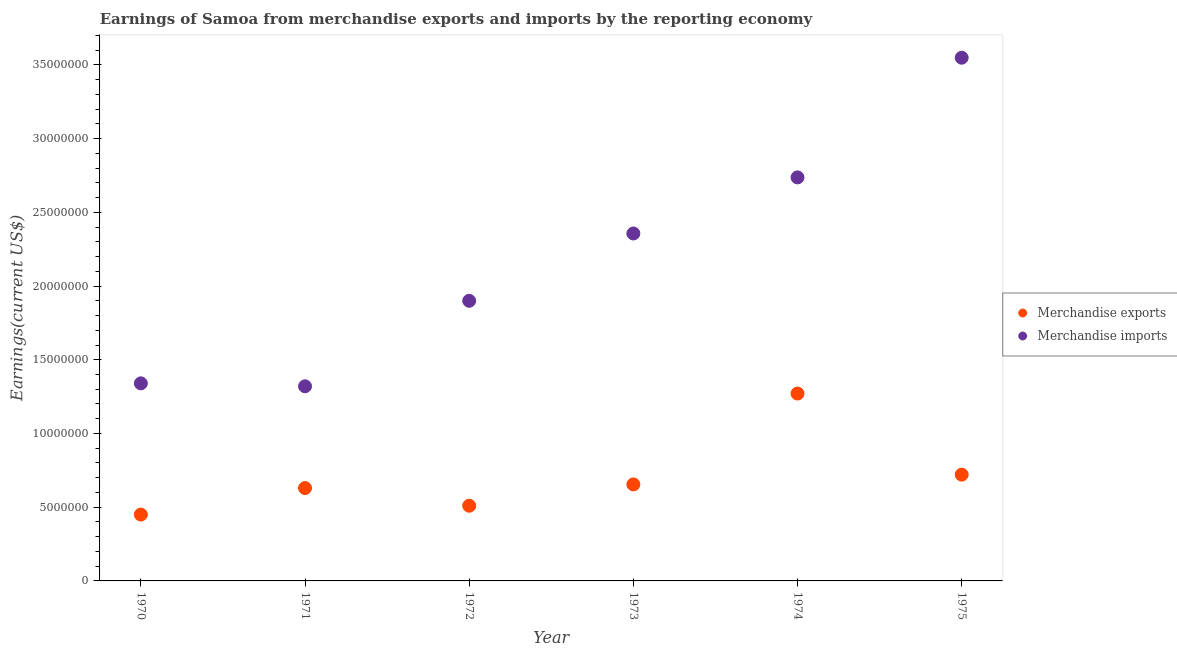What is the earnings from merchandise exports in 1972?
Your answer should be compact. 5.10e+06. Across all years, what is the maximum earnings from merchandise imports?
Ensure brevity in your answer.  3.55e+07. Across all years, what is the minimum earnings from merchandise imports?
Provide a short and direct response. 1.32e+07. In which year was the earnings from merchandise imports maximum?
Offer a terse response. 1975. In which year was the earnings from merchandise imports minimum?
Make the answer very short. 1971. What is the total earnings from merchandise exports in the graph?
Keep it short and to the point. 4.24e+07. What is the difference between the earnings from merchandise exports in 1972 and the earnings from merchandise imports in 1970?
Make the answer very short. -8.30e+06. What is the average earnings from merchandise imports per year?
Your answer should be very brief. 2.20e+07. In the year 1973, what is the difference between the earnings from merchandise exports and earnings from merchandise imports?
Your answer should be compact. -1.70e+07. What is the ratio of the earnings from merchandise exports in 1973 to that in 1974?
Your answer should be compact. 0.51. Is the earnings from merchandise exports in 1973 less than that in 1975?
Ensure brevity in your answer.  Yes. What is the difference between the highest and the second highest earnings from merchandise exports?
Offer a very short reply. 5.50e+06. What is the difference between the highest and the lowest earnings from merchandise imports?
Offer a very short reply. 2.23e+07. Does the earnings from merchandise exports monotonically increase over the years?
Your answer should be very brief. No. Is the earnings from merchandise imports strictly less than the earnings from merchandise exports over the years?
Offer a terse response. No. How many dotlines are there?
Your answer should be compact. 2. How many years are there in the graph?
Offer a terse response. 6. Are the values on the major ticks of Y-axis written in scientific E-notation?
Give a very brief answer. No. Does the graph contain any zero values?
Ensure brevity in your answer.  No. How many legend labels are there?
Your response must be concise. 2. How are the legend labels stacked?
Ensure brevity in your answer.  Vertical. What is the title of the graph?
Your answer should be very brief. Earnings of Samoa from merchandise exports and imports by the reporting economy. What is the label or title of the Y-axis?
Provide a succinct answer. Earnings(current US$). What is the Earnings(current US$) of Merchandise exports in 1970?
Make the answer very short. 4.50e+06. What is the Earnings(current US$) in Merchandise imports in 1970?
Provide a succinct answer. 1.34e+07. What is the Earnings(current US$) in Merchandise exports in 1971?
Offer a terse response. 6.30e+06. What is the Earnings(current US$) in Merchandise imports in 1971?
Your answer should be compact. 1.32e+07. What is the Earnings(current US$) in Merchandise exports in 1972?
Your answer should be compact. 5.10e+06. What is the Earnings(current US$) of Merchandise imports in 1972?
Keep it short and to the point. 1.90e+07. What is the Earnings(current US$) in Merchandise exports in 1973?
Your answer should be compact. 6.54e+06. What is the Earnings(current US$) of Merchandise imports in 1973?
Make the answer very short. 2.36e+07. What is the Earnings(current US$) in Merchandise exports in 1974?
Your answer should be compact. 1.27e+07. What is the Earnings(current US$) of Merchandise imports in 1974?
Make the answer very short. 2.74e+07. What is the Earnings(current US$) in Merchandise exports in 1975?
Provide a short and direct response. 7.21e+06. What is the Earnings(current US$) of Merchandise imports in 1975?
Make the answer very short. 3.55e+07. Across all years, what is the maximum Earnings(current US$) of Merchandise exports?
Your answer should be compact. 1.27e+07. Across all years, what is the maximum Earnings(current US$) in Merchandise imports?
Keep it short and to the point. 3.55e+07. Across all years, what is the minimum Earnings(current US$) in Merchandise exports?
Ensure brevity in your answer.  4.50e+06. Across all years, what is the minimum Earnings(current US$) in Merchandise imports?
Your response must be concise. 1.32e+07. What is the total Earnings(current US$) in Merchandise exports in the graph?
Provide a short and direct response. 4.24e+07. What is the total Earnings(current US$) of Merchandise imports in the graph?
Offer a very short reply. 1.32e+08. What is the difference between the Earnings(current US$) in Merchandise exports in 1970 and that in 1971?
Your response must be concise. -1.80e+06. What is the difference between the Earnings(current US$) of Merchandise imports in 1970 and that in 1971?
Provide a succinct answer. 2.00e+05. What is the difference between the Earnings(current US$) of Merchandise exports in 1970 and that in 1972?
Provide a succinct answer. -6.00e+05. What is the difference between the Earnings(current US$) in Merchandise imports in 1970 and that in 1972?
Your answer should be compact. -5.60e+06. What is the difference between the Earnings(current US$) of Merchandise exports in 1970 and that in 1973?
Ensure brevity in your answer.  -2.04e+06. What is the difference between the Earnings(current US$) in Merchandise imports in 1970 and that in 1973?
Provide a succinct answer. -1.02e+07. What is the difference between the Earnings(current US$) in Merchandise exports in 1970 and that in 1974?
Ensure brevity in your answer.  -8.21e+06. What is the difference between the Earnings(current US$) of Merchandise imports in 1970 and that in 1974?
Ensure brevity in your answer.  -1.40e+07. What is the difference between the Earnings(current US$) in Merchandise exports in 1970 and that in 1975?
Your response must be concise. -2.71e+06. What is the difference between the Earnings(current US$) in Merchandise imports in 1970 and that in 1975?
Give a very brief answer. -2.21e+07. What is the difference between the Earnings(current US$) in Merchandise exports in 1971 and that in 1972?
Provide a succinct answer. 1.20e+06. What is the difference between the Earnings(current US$) of Merchandise imports in 1971 and that in 1972?
Make the answer very short. -5.80e+06. What is the difference between the Earnings(current US$) in Merchandise exports in 1971 and that in 1973?
Give a very brief answer. -2.45e+05. What is the difference between the Earnings(current US$) in Merchandise imports in 1971 and that in 1973?
Make the answer very short. -1.04e+07. What is the difference between the Earnings(current US$) in Merchandise exports in 1971 and that in 1974?
Provide a succinct answer. -6.41e+06. What is the difference between the Earnings(current US$) of Merchandise imports in 1971 and that in 1974?
Provide a succinct answer. -1.42e+07. What is the difference between the Earnings(current US$) of Merchandise exports in 1971 and that in 1975?
Provide a succinct answer. -9.08e+05. What is the difference between the Earnings(current US$) in Merchandise imports in 1971 and that in 1975?
Your response must be concise. -2.23e+07. What is the difference between the Earnings(current US$) in Merchandise exports in 1972 and that in 1973?
Give a very brief answer. -1.44e+06. What is the difference between the Earnings(current US$) in Merchandise imports in 1972 and that in 1973?
Give a very brief answer. -4.56e+06. What is the difference between the Earnings(current US$) in Merchandise exports in 1972 and that in 1974?
Your answer should be compact. -7.61e+06. What is the difference between the Earnings(current US$) of Merchandise imports in 1972 and that in 1974?
Your answer should be compact. -8.37e+06. What is the difference between the Earnings(current US$) in Merchandise exports in 1972 and that in 1975?
Provide a succinct answer. -2.11e+06. What is the difference between the Earnings(current US$) in Merchandise imports in 1972 and that in 1975?
Ensure brevity in your answer.  -1.65e+07. What is the difference between the Earnings(current US$) of Merchandise exports in 1973 and that in 1974?
Provide a succinct answer. -6.16e+06. What is the difference between the Earnings(current US$) in Merchandise imports in 1973 and that in 1974?
Ensure brevity in your answer.  -3.80e+06. What is the difference between the Earnings(current US$) of Merchandise exports in 1973 and that in 1975?
Your answer should be compact. -6.63e+05. What is the difference between the Earnings(current US$) of Merchandise imports in 1973 and that in 1975?
Offer a very short reply. -1.19e+07. What is the difference between the Earnings(current US$) of Merchandise exports in 1974 and that in 1975?
Ensure brevity in your answer.  5.50e+06. What is the difference between the Earnings(current US$) in Merchandise imports in 1974 and that in 1975?
Your answer should be compact. -8.12e+06. What is the difference between the Earnings(current US$) of Merchandise exports in 1970 and the Earnings(current US$) of Merchandise imports in 1971?
Make the answer very short. -8.70e+06. What is the difference between the Earnings(current US$) of Merchandise exports in 1970 and the Earnings(current US$) of Merchandise imports in 1972?
Provide a succinct answer. -1.45e+07. What is the difference between the Earnings(current US$) in Merchandise exports in 1970 and the Earnings(current US$) in Merchandise imports in 1973?
Keep it short and to the point. -1.91e+07. What is the difference between the Earnings(current US$) in Merchandise exports in 1970 and the Earnings(current US$) in Merchandise imports in 1974?
Ensure brevity in your answer.  -2.29e+07. What is the difference between the Earnings(current US$) in Merchandise exports in 1970 and the Earnings(current US$) in Merchandise imports in 1975?
Make the answer very short. -3.10e+07. What is the difference between the Earnings(current US$) of Merchandise exports in 1971 and the Earnings(current US$) of Merchandise imports in 1972?
Your response must be concise. -1.27e+07. What is the difference between the Earnings(current US$) in Merchandise exports in 1971 and the Earnings(current US$) in Merchandise imports in 1973?
Your answer should be compact. -1.73e+07. What is the difference between the Earnings(current US$) of Merchandise exports in 1971 and the Earnings(current US$) of Merchandise imports in 1974?
Ensure brevity in your answer.  -2.11e+07. What is the difference between the Earnings(current US$) in Merchandise exports in 1971 and the Earnings(current US$) in Merchandise imports in 1975?
Your answer should be very brief. -2.92e+07. What is the difference between the Earnings(current US$) of Merchandise exports in 1972 and the Earnings(current US$) of Merchandise imports in 1973?
Your answer should be compact. -1.85e+07. What is the difference between the Earnings(current US$) in Merchandise exports in 1972 and the Earnings(current US$) in Merchandise imports in 1974?
Your answer should be compact. -2.23e+07. What is the difference between the Earnings(current US$) of Merchandise exports in 1972 and the Earnings(current US$) of Merchandise imports in 1975?
Your answer should be very brief. -3.04e+07. What is the difference between the Earnings(current US$) in Merchandise exports in 1973 and the Earnings(current US$) in Merchandise imports in 1974?
Give a very brief answer. -2.08e+07. What is the difference between the Earnings(current US$) of Merchandise exports in 1973 and the Earnings(current US$) of Merchandise imports in 1975?
Provide a short and direct response. -2.89e+07. What is the difference between the Earnings(current US$) of Merchandise exports in 1974 and the Earnings(current US$) of Merchandise imports in 1975?
Provide a short and direct response. -2.28e+07. What is the average Earnings(current US$) in Merchandise exports per year?
Your answer should be very brief. 7.06e+06. What is the average Earnings(current US$) in Merchandise imports per year?
Provide a short and direct response. 2.20e+07. In the year 1970, what is the difference between the Earnings(current US$) in Merchandise exports and Earnings(current US$) in Merchandise imports?
Provide a short and direct response. -8.90e+06. In the year 1971, what is the difference between the Earnings(current US$) of Merchandise exports and Earnings(current US$) of Merchandise imports?
Ensure brevity in your answer.  -6.90e+06. In the year 1972, what is the difference between the Earnings(current US$) of Merchandise exports and Earnings(current US$) of Merchandise imports?
Your answer should be compact. -1.39e+07. In the year 1973, what is the difference between the Earnings(current US$) of Merchandise exports and Earnings(current US$) of Merchandise imports?
Ensure brevity in your answer.  -1.70e+07. In the year 1974, what is the difference between the Earnings(current US$) in Merchandise exports and Earnings(current US$) in Merchandise imports?
Your answer should be very brief. -1.47e+07. In the year 1975, what is the difference between the Earnings(current US$) in Merchandise exports and Earnings(current US$) in Merchandise imports?
Your answer should be compact. -2.83e+07. What is the ratio of the Earnings(current US$) of Merchandise exports in 1970 to that in 1971?
Offer a very short reply. 0.71. What is the ratio of the Earnings(current US$) in Merchandise imports in 1970 to that in 1971?
Give a very brief answer. 1.02. What is the ratio of the Earnings(current US$) of Merchandise exports in 1970 to that in 1972?
Keep it short and to the point. 0.88. What is the ratio of the Earnings(current US$) in Merchandise imports in 1970 to that in 1972?
Offer a very short reply. 0.71. What is the ratio of the Earnings(current US$) in Merchandise exports in 1970 to that in 1973?
Ensure brevity in your answer.  0.69. What is the ratio of the Earnings(current US$) of Merchandise imports in 1970 to that in 1973?
Ensure brevity in your answer.  0.57. What is the ratio of the Earnings(current US$) of Merchandise exports in 1970 to that in 1974?
Give a very brief answer. 0.35. What is the ratio of the Earnings(current US$) in Merchandise imports in 1970 to that in 1974?
Keep it short and to the point. 0.49. What is the ratio of the Earnings(current US$) in Merchandise exports in 1970 to that in 1975?
Make the answer very short. 0.62. What is the ratio of the Earnings(current US$) of Merchandise imports in 1970 to that in 1975?
Provide a succinct answer. 0.38. What is the ratio of the Earnings(current US$) of Merchandise exports in 1971 to that in 1972?
Give a very brief answer. 1.24. What is the ratio of the Earnings(current US$) in Merchandise imports in 1971 to that in 1972?
Provide a succinct answer. 0.69. What is the ratio of the Earnings(current US$) of Merchandise exports in 1971 to that in 1973?
Offer a terse response. 0.96. What is the ratio of the Earnings(current US$) in Merchandise imports in 1971 to that in 1973?
Give a very brief answer. 0.56. What is the ratio of the Earnings(current US$) in Merchandise exports in 1971 to that in 1974?
Your answer should be very brief. 0.5. What is the ratio of the Earnings(current US$) in Merchandise imports in 1971 to that in 1974?
Make the answer very short. 0.48. What is the ratio of the Earnings(current US$) in Merchandise exports in 1971 to that in 1975?
Your answer should be very brief. 0.87. What is the ratio of the Earnings(current US$) of Merchandise imports in 1971 to that in 1975?
Provide a short and direct response. 0.37. What is the ratio of the Earnings(current US$) in Merchandise exports in 1972 to that in 1973?
Provide a short and direct response. 0.78. What is the ratio of the Earnings(current US$) in Merchandise imports in 1972 to that in 1973?
Offer a very short reply. 0.81. What is the ratio of the Earnings(current US$) of Merchandise exports in 1972 to that in 1974?
Provide a short and direct response. 0.4. What is the ratio of the Earnings(current US$) of Merchandise imports in 1972 to that in 1974?
Offer a terse response. 0.69. What is the ratio of the Earnings(current US$) in Merchandise exports in 1972 to that in 1975?
Offer a terse response. 0.71. What is the ratio of the Earnings(current US$) in Merchandise imports in 1972 to that in 1975?
Keep it short and to the point. 0.54. What is the ratio of the Earnings(current US$) of Merchandise exports in 1973 to that in 1974?
Your answer should be very brief. 0.52. What is the ratio of the Earnings(current US$) in Merchandise imports in 1973 to that in 1974?
Your answer should be very brief. 0.86. What is the ratio of the Earnings(current US$) in Merchandise exports in 1973 to that in 1975?
Ensure brevity in your answer.  0.91. What is the ratio of the Earnings(current US$) of Merchandise imports in 1973 to that in 1975?
Provide a succinct answer. 0.66. What is the ratio of the Earnings(current US$) in Merchandise exports in 1974 to that in 1975?
Offer a very short reply. 1.76. What is the ratio of the Earnings(current US$) of Merchandise imports in 1974 to that in 1975?
Give a very brief answer. 0.77. What is the difference between the highest and the second highest Earnings(current US$) in Merchandise exports?
Give a very brief answer. 5.50e+06. What is the difference between the highest and the second highest Earnings(current US$) of Merchandise imports?
Keep it short and to the point. 8.12e+06. What is the difference between the highest and the lowest Earnings(current US$) in Merchandise exports?
Make the answer very short. 8.21e+06. What is the difference between the highest and the lowest Earnings(current US$) in Merchandise imports?
Provide a short and direct response. 2.23e+07. 